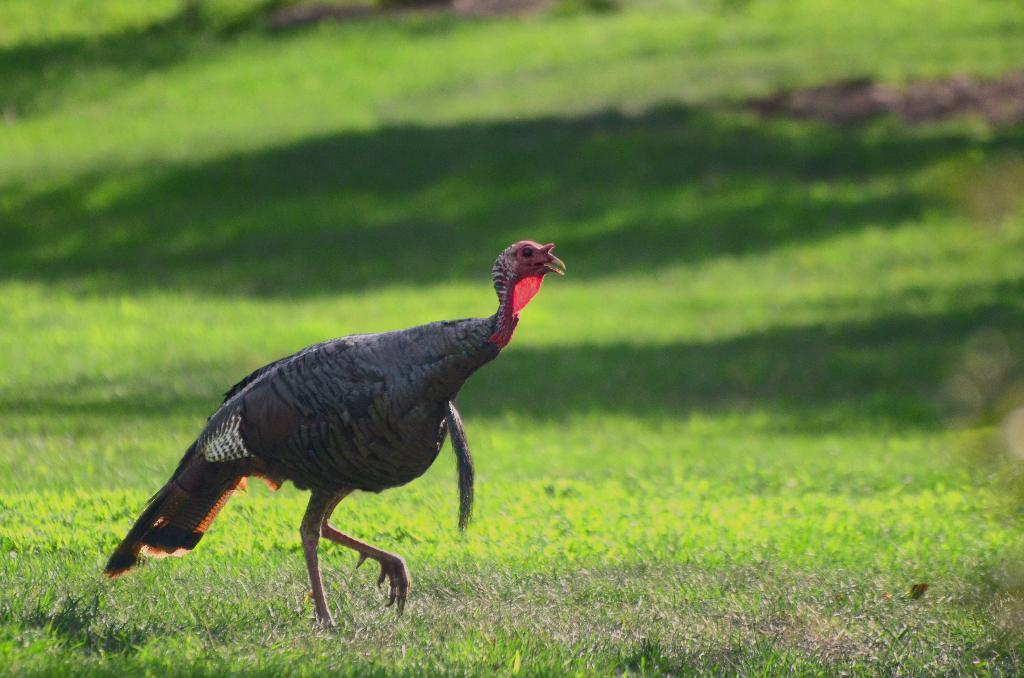What type of animal is present in the image? There is a bird in the image. Can you describe the bird's location in the image? The bird is on the ground in the image. What type of meeting is the bird attending in the image? There is no meeting present in the image; it simply features a bird on the ground. 